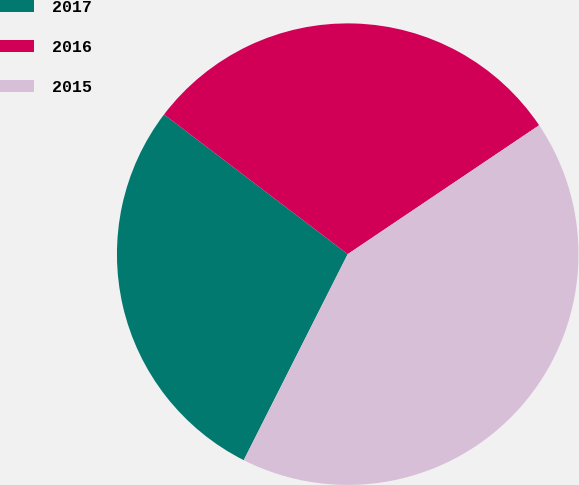<chart> <loc_0><loc_0><loc_500><loc_500><pie_chart><fcel>2017<fcel>2016<fcel>2015<nl><fcel>27.91%<fcel>30.22%<fcel>41.87%<nl></chart> 